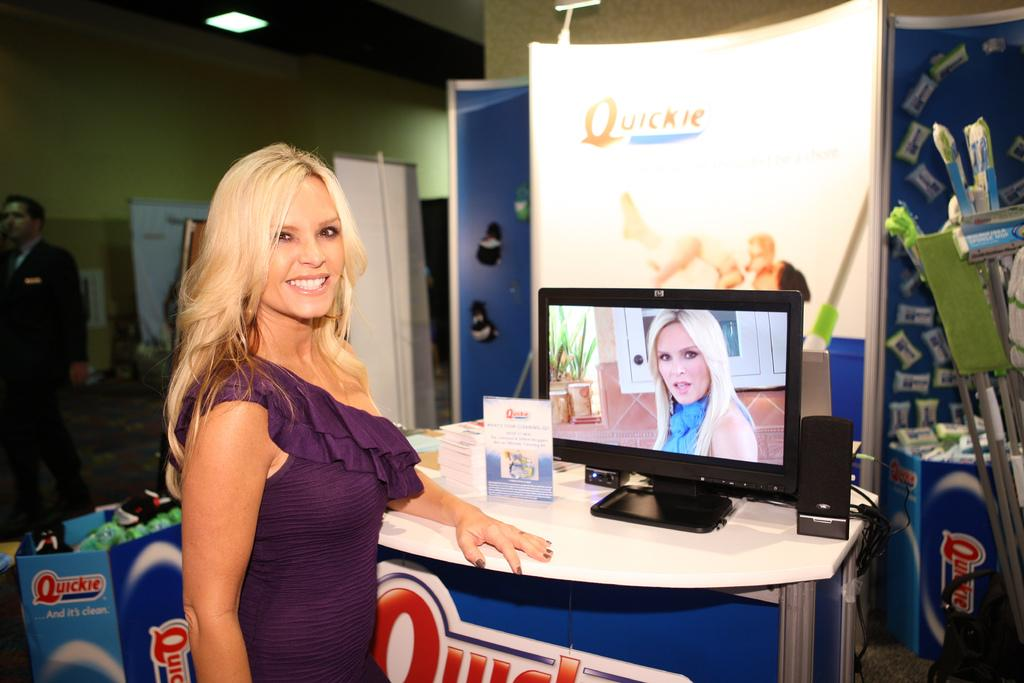<image>
Provide a brief description of the given image. a girl next to a sign that says quickie 